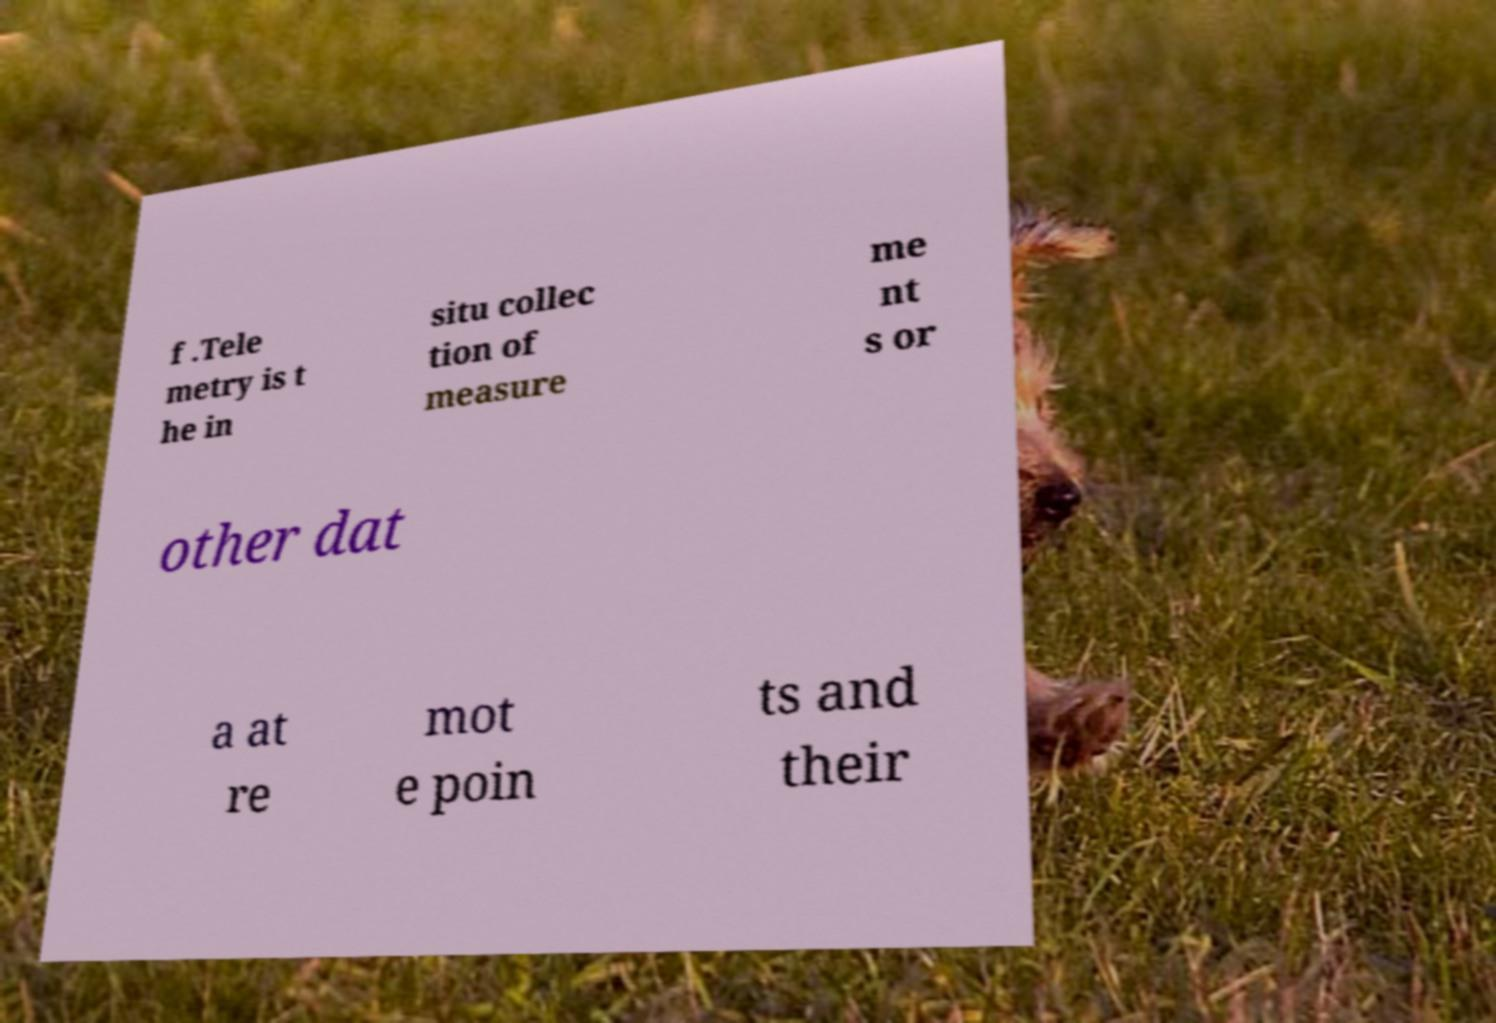Please identify and transcribe the text found in this image. f .Tele metry is t he in situ collec tion of measure me nt s or other dat a at re mot e poin ts and their 